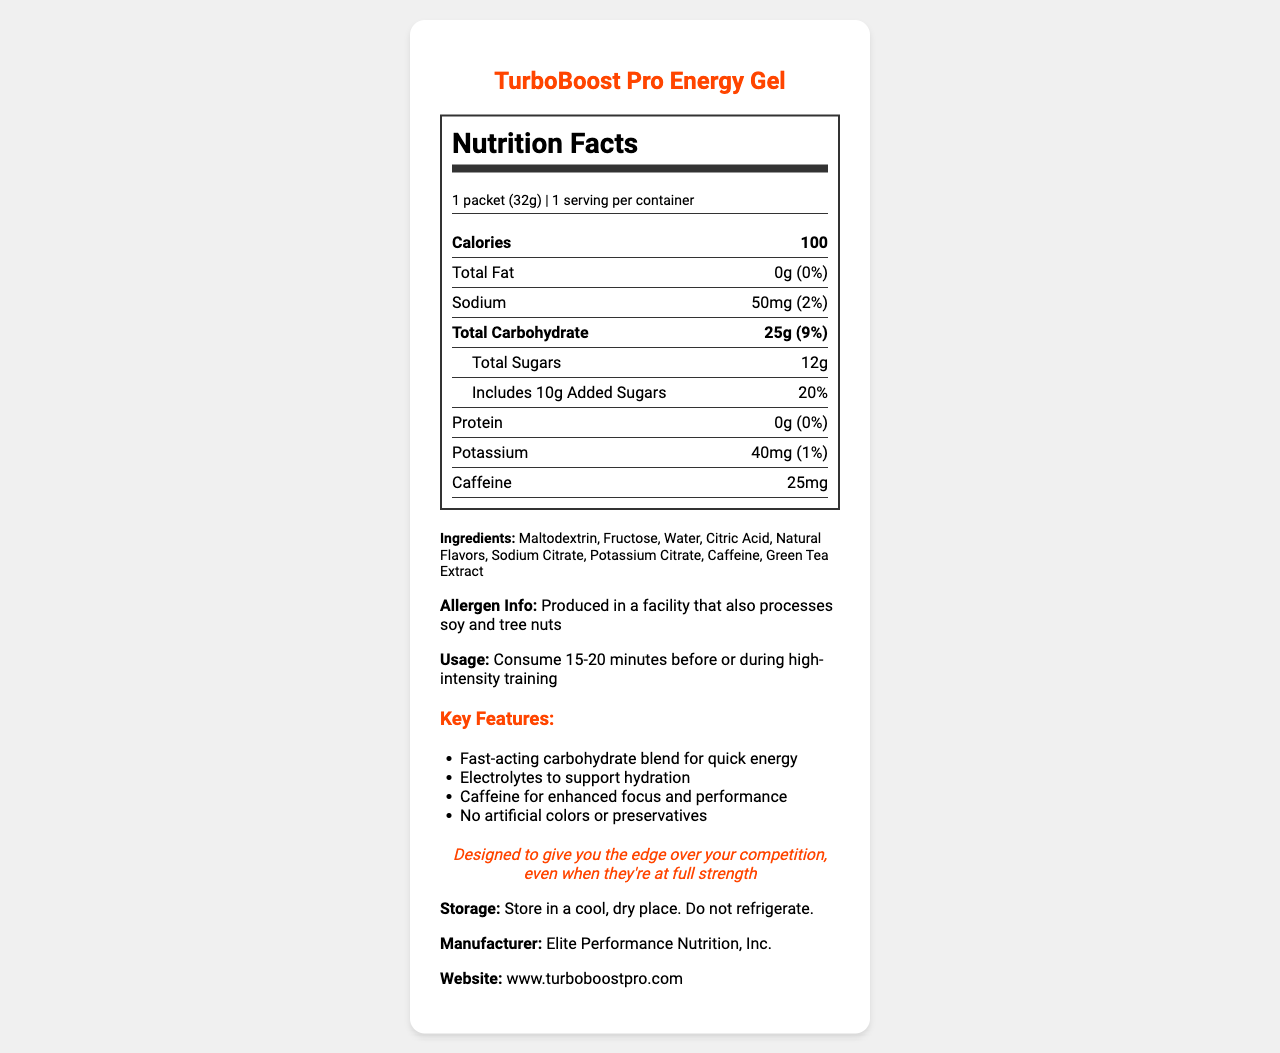What is the total carbohydrate content in one packet of TurboBoost Pro Energy Gel? The document states that the total carbohydrate content per serving size, which is one packet, is 25g.
Answer: 25g What are the usage instructions for TurboBoost Pro Energy Gel? The document specifies the usage instruction to be consumed 15-20 minutes before or during high-intensity training.
Answer: Consume 15-20 minutes before or during high-intensity training How much caffeine is in one packet of TurboBoost Pro Energy Gel? The document lists caffeine content as 25mg per packet.
Answer: 25mg What percentage of the daily value of sodium does one packet contain? The document mentions that one packet contains 50mg of sodium, which is 2% of the daily value.
Answer: 2% Does TurboBoost Pro Energy Gel contain any significant amount of protein? The document indicates that the protein content is 0g, which corresponds to 0% of the daily value.
Answer: No What are the primary sources of carbohydrates in TurboBoost Pro Energy Gel? A. Maltodextrin and Fructose B. Green Tea Extract and Citric Acid C. Water and Sodium Citrate The ingredients list in the document shows that Maltodextrin and Fructose are primary sources of carbohydrates.
Answer: A. Maltodextrin and Fructose How should TurboBoost Pro Energy Gel be stored? A. Refrigerated B. In a cool, dry place C. Exposed to sunlight The document specifies that the product should be stored in a cool, dry place.
Answer: B. In a cool, dry place Is TurboBoost Pro Energy Gel free from artificial colors and preservatives? The document states under "Key Features" that the product contains no artificial colors or preservatives.
Answer: Yes Summarize the key features of TurboBoost Pro Energy Gel. The document lists these key features, highlighting the gel's benefits for athletes.
Answer: TurboBoost Pro Energy Gel provides fast-acting carbohydrates for quick energy, electrolytes for hydration support, caffeine for enhanced focus and performance, and contains no artificial colors or preservatives. What is the percentage of daily value for added sugars in one packet? The document shows that 10g of added sugars is 20% of the daily value.
Answer: 20% What is the allergen information provided for TurboBoost Pro Energy Gel? The document provides this allergen information near the ingredients section.
Answer: Produced in a facility that also processes soy and tree nuts Can TurboBoost Pro Energy Gel be used as a sole source of nutrition? The document offers no information indicating that it is intended as a sole source of nutrition. It focuses only on its use during high-intensity training sessions.
Answer: Not enough information Who manufactures TurboBoost Pro Energy Gel? The document lists the manufacturer as Elite Performance Nutrition, Inc.
Answer: Elite Performance Nutrition, Inc. Does the product contain any significant amount of potassium? The potassium content is listed as 40mg, which is only 1% of the daily value, indicating it is not a significant amount.
Answer: No 